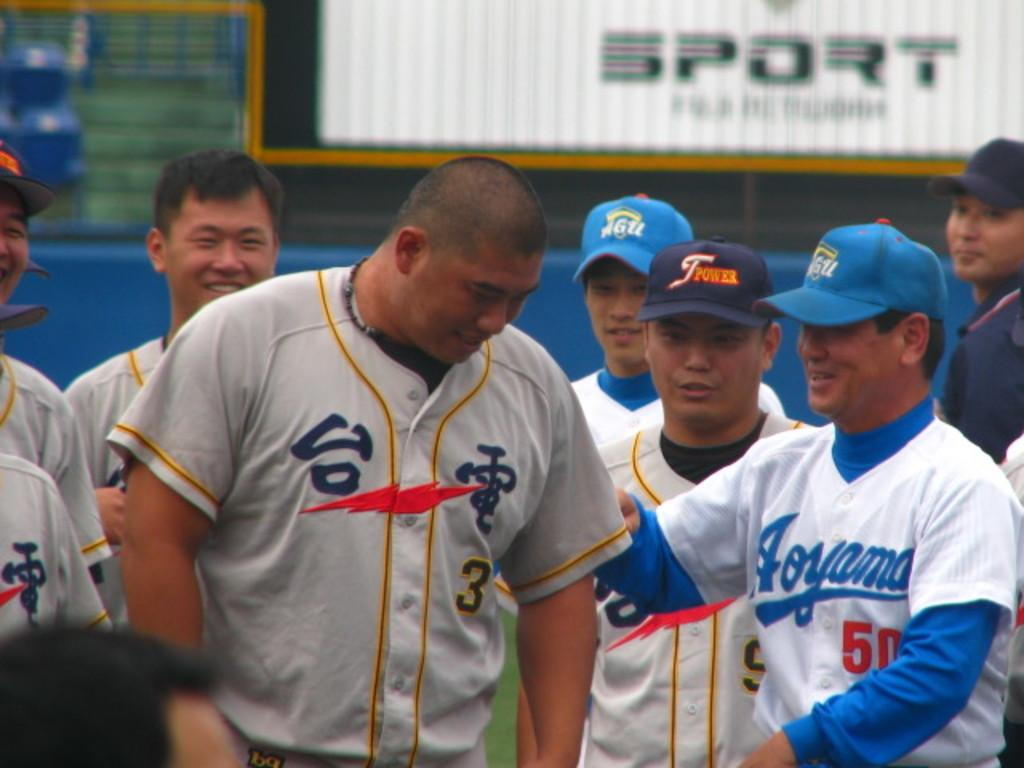Provide a one-sentence caption for the provided image. a few players with Japanese language on their jerseys with one man wearing 50. 